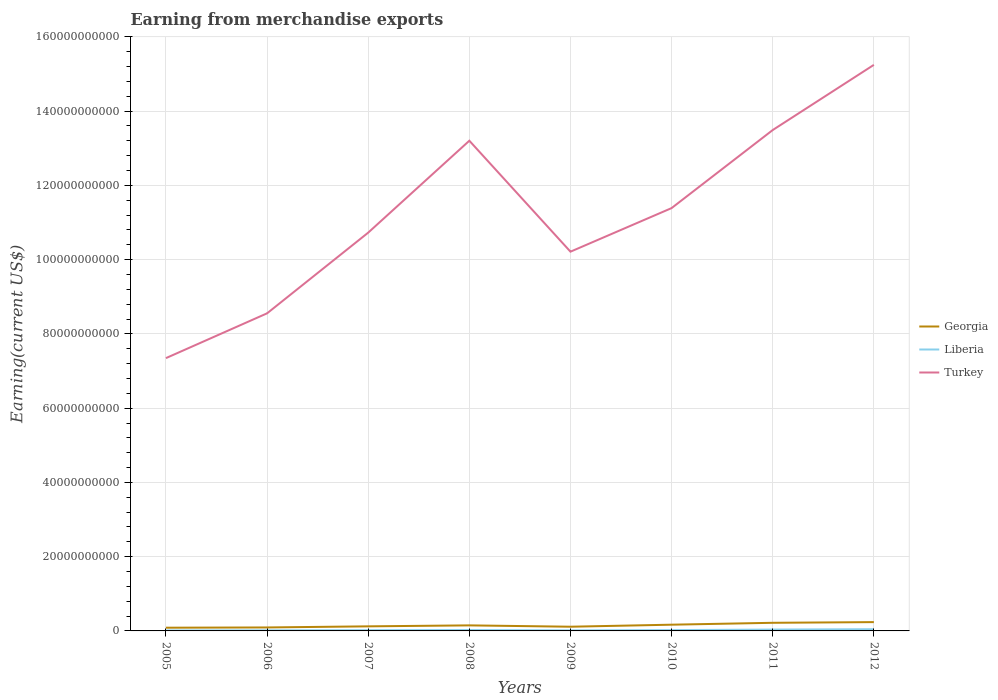How many different coloured lines are there?
Provide a short and direct response. 3. Does the line corresponding to Liberia intersect with the line corresponding to Georgia?
Your response must be concise. No. Across all years, what is the maximum amount earned from merchandise exports in Liberia?
Your answer should be compact. 1.31e+08. What is the total amount earned from merchandise exports in Georgia in the graph?
Provide a succinct answer. -6.30e+08. What is the difference between the highest and the second highest amount earned from merchandise exports in Turkey?
Your answer should be very brief. 7.90e+1. How many lines are there?
Make the answer very short. 3. How many years are there in the graph?
Your response must be concise. 8. Are the values on the major ticks of Y-axis written in scientific E-notation?
Provide a succinct answer. No. Does the graph contain any zero values?
Your response must be concise. No. Does the graph contain grids?
Provide a short and direct response. Yes. Where does the legend appear in the graph?
Offer a terse response. Center right. How many legend labels are there?
Provide a short and direct response. 3. How are the legend labels stacked?
Your response must be concise. Vertical. What is the title of the graph?
Your response must be concise. Earning from merchandise exports. What is the label or title of the X-axis?
Your response must be concise. Years. What is the label or title of the Y-axis?
Your answer should be compact. Earning(current US$). What is the Earning(current US$) in Georgia in 2005?
Ensure brevity in your answer.  8.65e+08. What is the Earning(current US$) of Liberia in 2005?
Provide a short and direct response. 1.31e+08. What is the Earning(current US$) of Turkey in 2005?
Provide a succinct answer. 7.35e+1. What is the Earning(current US$) in Georgia in 2006?
Ensure brevity in your answer.  9.36e+08. What is the Earning(current US$) of Liberia in 2006?
Make the answer very short. 1.58e+08. What is the Earning(current US$) of Turkey in 2006?
Your response must be concise. 8.55e+1. What is the Earning(current US$) in Georgia in 2007?
Offer a terse response. 1.23e+09. What is the Earning(current US$) in Liberia in 2007?
Your answer should be compact. 2.00e+08. What is the Earning(current US$) of Turkey in 2007?
Provide a succinct answer. 1.07e+11. What is the Earning(current US$) of Georgia in 2008?
Keep it short and to the point. 1.50e+09. What is the Earning(current US$) of Liberia in 2008?
Your response must be concise. 2.42e+08. What is the Earning(current US$) of Turkey in 2008?
Provide a short and direct response. 1.32e+11. What is the Earning(current US$) of Georgia in 2009?
Offer a very short reply. 1.13e+09. What is the Earning(current US$) of Liberia in 2009?
Ensure brevity in your answer.  1.49e+08. What is the Earning(current US$) of Turkey in 2009?
Keep it short and to the point. 1.02e+11. What is the Earning(current US$) in Georgia in 2010?
Your answer should be very brief. 1.68e+09. What is the Earning(current US$) in Liberia in 2010?
Give a very brief answer. 2.22e+08. What is the Earning(current US$) in Turkey in 2010?
Offer a very short reply. 1.14e+11. What is the Earning(current US$) of Georgia in 2011?
Offer a terse response. 2.19e+09. What is the Earning(current US$) of Liberia in 2011?
Ensure brevity in your answer.  3.67e+08. What is the Earning(current US$) in Turkey in 2011?
Offer a very short reply. 1.35e+11. What is the Earning(current US$) in Georgia in 2012?
Offer a terse response. 2.38e+09. What is the Earning(current US$) in Liberia in 2012?
Ensure brevity in your answer.  4.60e+08. What is the Earning(current US$) of Turkey in 2012?
Ensure brevity in your answer.  1.52e+11. Across all years, what is the maximum Earning(current US$) of Georgia?
Make the answer very short. 2.38e+09. Across all years, what is the maximum Earning(current US$) in Liberia?
Your response must be concise. 4.60e+08. Across all years, what is the maximum Earning(current US$) of Turkey?
Offer a very short reply. 1.52e+11. Across all years, what is the minimum Earning(current US$) in Georgia?
Your response must be concise. 8.65e+08. Across all years, what is the minimum Earning(current US$) in Liberia?
Offer a very short reply. 1.31e+08. Across all years, what is the minimum Earning(current US$) of Turkey?
Ensure brevity in your answer.  7.35e+1. What is the total Earning(current US$) of Georgia in the graph?
Make the answer very short. 1.19e+1. What is the total Earning(current US$) in Liberia in the graph?
Give a very brief answer. 1.93e+09. What is the total Earning(current US$) in Turkey in the graph?
Your answer should be very brief. 9.02e+11. What is the difference between the Earning(current US$) of Georgia in 2005 and that in 2006?
Your answer should be compact. -7.12e+07. What is the difference between the Earning(current US$) in Liberia in 2005 and that in 2006?
Your answer should be very brief. -2.65e+07. What is the difference between the Earning(current US$) in Turkey in 2005 and that in 2006?
Provide a short and direct response. -1.21e+1. What is the difference between the Earning(current US$) of Georgia in 2005 and that in 2007?
Make the answer very short. -3.67e+08. What is the difference between the Earning(current US$) of Liberia in 2005 and that in 2007?
Your response must be concise. -6.89e+07. What is the difference between the Earning(current US$) of Turkey in 2005 and that in 2007?
Ensure brevity in your answer.  -3.38e+1. What is the difference between the Earning(current US$) of Georgia in 2005 and that in 2008?
Provide a succinct answer. -6.30e+08. What is the difference between the Earning(current US$) in Liberia in 2005 and that in 2008?
Provide a succinct answer. -1.11e+08. What is the difference between the Earning(current US$) in Turkey in 2005 and that in 2008?
Offer a very short reply. -5.86e+1. What is the difference between the Earning(current US$) of Georgia in 2005 and that in 2009?
Ensure brevity in your answer.  -2.69e+08. What is the difference between the Earning(current US$) in Liberia in 2005 and that in 2009?
Offer a terse response. -1.75e+07. What is the difference between the Earning(current US$) of Turkey in 2005 and that in 2009?
Offer a very short reply. -2.87e+1. What is the difference between the Earning(current US$) of Georgia in 2005 and that in 2010?
Offer a terse response. -8.12e+08. What is the difference between the Earning(current US$) in Liberia in 2005 and that in 2010?
Give a very brief answer. -9.07e+07. What is the difference between the Earning(current US$) of Turkey in 2005 and that in 2010?
Your answer should be very brief. -4.04e+1. What is the difference between the Earning(current US$) of Georgia in 2005 and that in 2011?
Make the answer very short. -1.32e+09. What is the difference between the Earning(current US$) of Liberia in 2005 and that in 2011?
Give a very brief answer. -2.36e+08. What is the difference between the Earning(current US$) in Turkey in 2005 and that in 2011?
Offer a very short reply. -6.14e+1. What is the difference between the Earning(current US$) in Georgia in 2005 and that in 2012?
Keep it short and to the point. -1.51e+09. What is the difference between the Earning(current US$) of Liberia in 2005 and that in 2012?
Make the answer very short. -3.28e+08. What is the difference between the Earning(current US$) in Turkey in 2005 and that in 2012?
Offer a terse response. -7.90e+1. What is the difference between the Earning(current US$) in Georgia in 2006 and that in 2007?
Provide a short and direct response. -2.96e+08. What is the difference between the Earning(current US$) in Liberia in 2006 and that in 2007?
Make the answer very short. -4.24e+07. What is the difference between the Earning(current US$) in Turkey in 2006 and that in 2007?
Ensure brevity in your answer.  -2.17e+1. What is the difference between the Earning(current US$) of Georgia in 2006 and that in 2008?
Give a very brief answer. -5.59e+08. What is the difference between the Earning(current US$) in Liberia in 2006 and that in 2008?
Your answer should be compact. -8.46e+07. What is the difference between the Earning(current US$) of Turkey in 2006 and that in 2008?
Keep it short and to the point. -4.65e+1. What is the difference between the Earning(current US$) in Georgia in 2006 and that in 2009?
Give a very brief answer. -1.97e+08. What is the difference between the Earning(current US$) in Liberia in 2006 and that in 2009?
Give a very brief answer. 8.97e+06. What is the difference between the Earning(current US$) in Turkey in 2006 and that in 2009?
Provide a succinct answer. -1.66e+1. What is the difference between the Earning(current US$) in Georgia in 2006 and that in 2010?
Keep it short and to the point. -7.41e+08. What is the difference between the Earning(current US$) in Liberia in 2006 and that in 2010?
Keep it short and to the point. -6.42e+07. What is the difference between the Earning(current US$) of Turkey in 2006 and that in 2010?
Your response must be concise. -2.83e+1. What is the difference between the Earning(current US$) of Georgia in 2006 and that in 2011?
Offer a very short reply. -1.25e+09. What is the difference between the Earning(current US$) of Liberia in 2006 and that in 2011?
Provide a short and direct response. -2.09e+08. What is the difference between the Earning(current US$) of Turkey in 2006 and that in 2011?
Offer a terse response. -4.94e+1. What is the difference between the Earning(current US$) in Georgia in 2006 and that in 2012?
Your answer should be very brief. -1.44e+09. What is the difference between the Earning(current US$) of Liberia in 2006 and that in 2012?
Ensure brevity in your answer.  -3.02e+08. What is the difference between the Earning(current US$) in Turkey in 2006 and that in 2012?
Your answer should be compact. -6.69e+1. What is the difference between the Earning(current US$) in Georgia in 2007 and that in 2008?
Make the answer very short. -2.63e+08. What is the difference between the Earning(current US$) in Liberia in 2007 and that in 2008?
Provide a short and direct response. -4.22e+07. What is the difference between the Earning(current US$) of Turkey in 2007 and that in 2008?
Keep it short and to the point. -2.48e+1. What is the difference between the Earning(current US$) of Georgia in 2007 and that in 2009?
Provide a succinct answer. 9.85e+07. What is the difference between the Earning(current US$) of Liberia in 2007 and that in 2009?
Provide a short and direct response. 5.14e+07. What is the difference between the Earning(current US$) in Turkey in 2007 and that in 2009?
Your response must be concise. 5.13e+09. What is the difference between the Earning(current US$) of Georgia in 2007 and that in 2010?
Give a very brief answer. -4.45e+08. What is the difference between the Earning(current US$) in Liberia in 2007 and that in 2010?
Make the answer very short. -2.18e+07. What is the difference between the Earning(current US$) of Turkey in 2007 and that in 2010?
Your response must be concise. -6.61e+09. What is the difference between the Earning(current US$) in Georgia in 2007 and that in 2011?
Provide a short and direct response. -9.57e+08. What is the difference between the Earning(current US$) in Liberia in 2007 and that in 2011?
Keep it short and to the point. -1.67e+08. What is the difference between the Earning(current US$) in Turkey in 2007 and that in 2011?
Your response must be concise. -2.76e+1. What is the difference between the Earning(current US$) of Georgia in 2007 and that in 2012?
Give a very brief answer. -1.14e+09. What is the difference between the Earning(current US$) of Liberia in 2007 and that in 2012?
Offer a terse response. -2.59e+08. What is the difference between the Earning(current US$) of Turkey in 2007 and that in 2012?
Make the answer very short. -4.52e+1. What is the difference between the Earning(current US$) in Georgia in 2008 and that in 2009?
Your response must be concise. 3.62e+08. What is the difference between the Earning(current US$) of Liberia in 2008 and that in 2009?
Your answer should be compact. 9.36e+07. What is the difference between the Earning(current US$) in Turkey in 2008 and that in 2009?
Your response must be concise. 2.99e+1. What is the difference between the Earning(current US$) in Georgia in 2008 and that in 2010?
Your answer should be compact. -1.82e+08. What is the difference between the Earning(current US$) in Liberia in 2008 and that in 2010?
Give a very brief answer. 2.04e+07. What is the difference between the Earning(current US$) in Turkey in 2008 and that in 2010?
Give a very brief answer. 1.81e+1. What is the difference between the Earning(current US$) of Georgia in 2008 and that in 2011?
Your answer should be compact. -6.94e+08. What is the difference between the Earning(current US$) in Liberia in 2008 and that in 2011?
Offer a terse response. -1.25e+08. What is the difference between the Earning(current US$) in Turkey in 2008 and that in 2011?
Provide a short and direct response. -2.88e+09. What is the difference between the Earning(current US$) of Georgia in 2008 and that in 2012?
Offer a terse response. -8.80e+08. What is the difference between the Earning(current US$) of Liberia in 2008 and that in 2012?
Provide a short and direct response. -2.17e+08. What is the difference between the Earning(current US$) in Turkey in 2008 and that in 2012?
Your answer should be very brief. -2.04e+1. What is the difference between the Earning(current US$) of Georgia in 2009 and that in 2010?
Provide a succinct answer. -5.43e+08. What is the difference between the Earning(current US$) in Liberia in 2009 and that in 2010?
Keep it short and to the point. -7.32e+07. What is the difference between the Earning(current US$) of Turkey in 2009 and that in 2010?
Provide a succinct answer. -1.17e+1. What is the difference between the Earning(current US$) in Georgia in 2009 and that in 2011?
Make the answer very short. -1.06e+09. What is the difference between the Earning(current US$) in Liberia in 2009 and that in 2011?
Offer a terse response. -2.18e+08. What is the difference between the Earning(current US$) of Turkey in 2009 and that in 2011?
Make the answer very short. -3.28e+1. What is the difference between the Earning(current US$) of Georgia in 2009 and that in 2012?
Ensure brevity in your answer.  -1.24e+09. What is the difference between the Earning(current US$) in Liberia in 2009 and that in 2012?
Keep it short and to the point. -3.11e+08. What is the difference between the Earning(current US$) in Turkey in 2009 and that in 2012?
Your answer should be compact. -5.03e+1. What is the difference between the Earning(current US$) in Georgia in 2010 and that in 2011?
Provide a short and direct response. -5.12e+08. What is the difference between the Earning(current US$) in Liberia in 2010 and that in 2011?
Provide a succinct answer. -1.45e+08. What is the difference between the Earning(current US$) of Turkey in 2010 and that in 2011?
Your answer should be compact. -2.10e+1. What is the difference between the Earning(current US$) in Georgia in 2010 and that in 2012?
Keep it short and to the point. -6.98e+08. What is the difference between the Earning(current US$) of Liberia in 2010 and that in 2012?
Offer a terse response. -2.38e+08. What is the difference between the Earning(current US$) in Turkey in 2010 and that in 2012?
Your answer should be very brief. -3.86e+1. What is the difference between the Earning(current US$) in Georgia in 2011 and that in 2012?
Your response must be concise. -1.86e+08. What is the difference between the Earning(current US$) of Liberia in 2011 and that in 2012?
Provide a short and direct response. -9.25e+07. What is the difference between the Earning(current US$) of Turkey in 2011 and that in 2012?
Offer a very short reply. -1.76e+1. What is the difference between the Earning(current US$) of Georgia in 2005 and the Earning(current US$) of Liberia in 2006?
Offer a very short reply. 7.07e+08. What is the difference between the Earning(current US$) in Georgia in 2005 and the Earning(current US$) in Turkey in 2006?
Make the answer very short. -8.47e+1. What is the difference between the Earning(current US$) in Liberia in 2005 and the Earning(current US$) in Turkey in 2006?
Provide a short and direct response. -8.54e+1. What is the difference between the Earning(current US$) of Georgia in 2005 and the Earning(current US$) of Liberia in 2007?
Your answer should be compact. 6.65e+08. What is the difference between the Earning(current US$) of Georgia in 2005 and the Earning(current US$) of Turkey in 2007?
Offer a very short reply. -1.06e+11. What is the difference between the Earning(current US$) in Liberia in 2005 and the Earning(current US$) in Turkey in 2007?
Ensure brevity in your answer.  -1.07e+11. What is the difference between the Earning(current US$) of Georgia in 2005 and the Earning(current US$) of Liberia in 2008?
Make the answer very short. 6.23e+08. What is the difference between the Earning(current US$) in Georgia in 2005 and the Earning(current US$) in Turkey in 2008?
Your response must be concise. -1.31e+11. What is the difference between the Earning(current US$) of Liberia in 2005 and the Earning(current US$) of Turkey in 2008?
Give a very brief answer. -1.32e+11. What is the difference between the Earning(current US$) of Georgia in 2005 and the Earning(current US$) of Liberia in 2009?
Ensure brevity in your answer.  7.16e+08. What is the difference between the Earning(current US$) of Georgia in 2005 and the Earning(current US$) of Turkey in 2009?
Your response must be concise. -1.01e+11. What is the difference between the Earning(current US$) in Liberia in 2005 and the Earning(current US$) in Turkey in 2009?
Ensure brevity in your answer.  -1.02e+11. What is the difference between the Earning(current US$) of Georgia in 2005 and the Earning(current US$) of Liberia in 2010?
Your answer should be very brief. 6.43e+08. What is the difference between the Earning(current US$) in Georgia in 2005 and the Earning(current US$) in Turkey in 2010?
Keep it short and to the point. -1.13e+11. What is the difference between the Earning(current US$) in Liberia in 2005 and the Earning(current US$) in Turkey in 2010?
Your answer should be compact. -1.14e+11. What is the difference between the Earning(current US$) in Georgia in 2005 and the Earning(current US$) in Liberia in 2011?
Your answer should be very brief. 4.98e+08. What is the difference between the Earning(current US$) in Georgia in 2005 and the Earning(current US$) in Turkey in 2011?
Offer a very short reply. -1.34e+11. What is the difference between the Earning(current US$) in Liberia in 2005 and the Earning(current US$) in Turkey in 2011?
Offer a very short reply. -1.35e+11. What is the difference between the Earning(current US$) in Georgia in 2005 and the Earning(current US$) in Liberia in 2012?
Ensure brevity in your answer.  4.06e+08. What is the difference between the Earning(current US$) in Georgia in 2005 and the Earning(current US$) in Turkey in 2012?
Provide a short and direct response. -1.52e+11. What is the difference between the Earning(current US$) in Liberia in 2005 and the Earning(current US$) in Turkey in 2012?
Provide a succinct answer. -1.52e+11. What is the difference between the Earning(current US$) of Georgia in 2006 and the Earning(current US$) of Liberia in 2007?
Provide a succinct answer. 7.36e+08. What is the difference between the Earning(current US$) of Georgia in 2006 and the Earning(current US$) of Turkey in 2007?
Keep it short and to the point. -1.06e+11. What is the difference between the Earning(current US$) in Liberia in 2006 and the Earning(current US$) in Turkey in 2007?
Offer a terse response. -1.07e+11. What is the difference between the Earning(current US$) in Georgia in 2006 and the Earning(current US$) in Liberia in 2008?
Your answer should be compact. 6.94e+08. What is the difference between the Earning(current US$) of Georgia in 2006 and the Earning(current US$) of Turkey in 2008?
Offer a terse response. -1.31e+11. What is the difference between the Earning(current US$) of Liberia in 2006 and the Earning(current US$) of Turkey in 2008?
Keep it short and to the point. -1.32e+11. What is the difference between the Earning(current US$) in Georgia in 2006 and the Earning(current US$) in Liberia in 2009?
Ensure brevity in your answer.  7.87e+08. What is the difference between the Earning(current US$) in Georgia in 2006 and the Earning(current US$) in Turkey in 2009?
Your response must be concise. -1.01e+11. What is the difference between the Earning(current US$) of Liberia in 2006 and the Earning(current US$) of Turkey in 2009?
Provide a succinct answer. -1.02e+11. What is the difference between the Earning(current US$) of Georgia in 2006 and the Earning(current US$) of Liberia in 2010?
Keep it short and to the point. 7.14e+08. What is the difference between the Earning(current US$) in Georgia in 2006 and the Earning(current US$) in Turkey in 2010?
Offer a terse response. -1.13e+11. What is the difference between the Earning(current US$) in Liberia in 2006 and the Earning(current US$) in Turkey in 2010?
Offer a terse response. -1.14e+11. What is the difference between the Earning(current US$) in Georgia in 2006 and the Earning(current US$) in Liberia in 2011?
Your answer should be very brief. 5.69e+08. What is the difference between the Earning(current US$) of Georgia in 2006 and the Earning(current US$) of Turkey in 2011?
Your response must be concise. -1.34e+11. What is the difference between the Earning(current US$) in Liberia in 2006 and the Earning(current US$) in Turkey in 2011?
Your answer should be compact. -1.35e+11. What is the difference between the Earning(current US$) of Georgia in 2006 and the Earning(current US$) of Liberia in 2012?
Make the answer very short. 4.77e+08. What is the difference between the Earning(current US$) of Georgia in 2006 and the Earning(current US$) of Turkey in 2012?
Your response must be concise. -1.52e+11. What is the difference between the Earning(current US$) of Liberia in 2006 and the Earning(current US$) of Turkey in 2012?
Provide a short and direct response. -1.52e+11. What is the difference between the Earning(current US$) in Georgia in 2007 and the Earning(current US$) in Liberia in 2008?
Provide a succinct answer. 9.90e+08. What is the difference between the Earning(current US$) of Georgia in 2007 and the Earning(current US$) of Turkey in 2008?
Keep it short and to the point. -1.31e+11. What is the difference between the Earning(current US$) in Liberia in 2007 and the Earning(current US$) in Turkey in 2008?
Ensure brevity in your answer.  -1.32e+11. What is the difference between the Earning(current US$) in Georgia in 2007 and the Earning(current US$) in Liberia in 2009?
Provide a succinct answer. 1.08e+09. What is the difference between the Earning(current US$) of Georgia in 2007 and the Earning(current US$) of Turkey in 2009?
Your answer should be very brief. -1.01e+11. What is the difference between the Earning(current US$) in Liberia in 2007 and the Earning(current US$) in Turkey in 2009?
Your answer should be compact. -1.02e+11. What is the difference between the Earning(current US$) of Georgia in 2007 and the Earning(current US$) of Liberia in 2010?
Your answer should be very brief. 1.01e+09. What is the difference between the Earning(current US$) in Georgia in 2007 and the Earning(current US$) in Turkey in 2010?
Offer a very short reply. -1.13e+11. What is the difference between the Earning(current US$) in Liberia in 2007 and the Earning(current US$) in Turkey in 2010?
Your answer should be very brief. -1.14e+11. What is the difference between the Earning(current US$) of Georgia in 2007 and the Earning(current US$) of Liberia in 2011?
Your answer should be compact. 8.65e+08. What is the difference between the Earning(current US$) in Georgia in 2007 and the Earning(current US$) in Turkey in 2011?
Give a very brief answer. -1.34e+11. What is the difference between the Earning(current US$) in Liberia in 2007 and the Earning(current US$) in Turkey in 2011?
Keep it short and to the point. -1.35e+11. What is the difference between the Earning(current US$) in Georgia in 2007 and the Earning(current US$) in Liberia in 2012?
Give a very brief answer. 7.73e+08. What is the difference between the Earning(current US$) of Georgia in 2007 and the Earning(current US$) of Turkey in 2012?
Your response must be concise. -1.51e+11. What is the difference between the Earning(current US$) in Liberia in 2007 and the Earning(current US$) in Turkey in 2012?
Your answer should be compact. -1.52e+11. What is the difference between the Earning(current US$) in Georgia in 2008 and the Earning(current US$) in Liberia in 2009?
Provide a short and direct response. 1.35e+09. What is the difference between the Earning(current US$) of Georgia in 2008 and the Earning(current US$) of Turkey in 2009?
Your answer should be very brief. -1.01e+11. What is the difference between the Earning(current US$) in Liberia in 2008 and the Earning(current US$) in Turkey in 2009?
Offer a very short reply. -1.02e+11. What is the difference between the Earning(current US$) of Georgia in 2008 and the Earning(current US$) of Liberia in 2010?
Make the answer very short. 1.27e+09. What is the difference between the Earning(current US$) in Georgia in 2008 and the Earning(current US$) in Turkey in 2010?
Offer a very short reply. -1.12e+11. What is the difference between the Earning(current US$) of Liberia in 2008 and the Earning(current US$) of Turkey in 2010?
Your answer should be compact. -1.14e+11. What is the difference between the Earning(current US$) in Georgia in 2008 and the Earning(current US$) in Liberia in 2011?
Give a very brief answer. 1.13e+09. What is the difference between the Earning(current US$) in Georgia in 2008 and the Earning(current US$) in Turkey in 2011?
Ensure brevity in your answer.  -1.33e+11. What is the difference between the Earning(current US$) in Liberia in 2008 and the Earning(current US$) in Turkey in 2011?
Make the answer very short. -1.35e+11. What is the difference between the Earning(current US$) in Georgia in 2008 and the Earning(current US$) in Liberia in 2012?
Offer a terse response. 1.04e+09. What is the difference between the Earning(current US$) in Georgia in 2008 and the Earning(current US$) in Turkey in 2012?
Your answer should be very brief. -1.51e+11. What is the difference between the Earning(current US$) in Liberia in 2008 and the Earning(current US$) in Turkey in 2012?
Offer a terse response. -1.52e+11. What is the difference between the Earning(current US$) of Georgia in 2009 and the Earning(current US$) of Liberia in 2010?
Your response must be concise. 9.12e+08. What is the difference between the Earning(current US$) in Georgia in 2009 and the Earning(current US$) in Turkey in 2010?
Your answer should be compact. -1.13e+11. What is the difference between the Earning(current US$) of Liberia in 2009 and the Earning(current US$) of Turkey in 2010?
Your response must be concise. -1.14e+11. What is the difference between the Earning(current US$) in Georgia in 2009 and the Earning(current US$) in Liberia in 2011?
Your response must be concise. 7.67e+08. What is the difference between the Earning(current US$) of Georgia in 2009 and the Earning(current US$) of Turkey in 2011?
Keep it short and to the point. -1.34e+11. What is the difference between the Earning(current US$) of Liberia in 2009 and the Earning(current US$) of Turkey in 2011?
Ensure brevity in your answer.  -1.35e+11. What is the difference between the Earning(current US$) in Georgia in 2009 and the Earning(current US$) in Liberia in 2012?
Provide a short and direct response. 6.74e+08. What is the difference between the Earning(current US$) of Georgia in 2009 and the Earning(current US$) of Turkey in 2012?
Provide a succinct answer. -1.51e+11. What is the difference between the Earning(current US$) in Liberia in 2009 and the Earning(current US$) in Turkey in 2012?
Ensure brevity in your answer.  -1.52e+11. What is the difference between the Earning(current US$) of Georgia in 2010 and the Earning(current US$) of Liberia in 2011?
Provide a short and direct response. 1.31e+09. What is the difference between the Earning(current US$) of Georgia in 2010 and the Earning(current US$) of Turkey in 2011?
Give a very brief answer. -1.33e+11. What is the difference between the Earning(current US$) in Liberia in 2010 and the Earning(current US$) in Turkey in 2011?
Your response must be concise. -1.35e+11. What is the difference between the Earning(current US$) in Georgia in 2010 and the Earning(current US$) in Liberia in 2012?
Provide a succinct answer. 1.22e+09. What is the difference between the Earning(current US$) of Georgia in 2010 and the Earning(current US$) of Turkey in 2012?
Give a very brief answer. -1.51e+11. What is the difference between the Earning(current US$) of Liberia in 2010 and the Earning(current US$) of Turkey in 2012?
Give a very brief answer. -1.52e+11. What is the difference between the Earning(current US$) of Georgia in 2011 and the Earning(current US$) of Liberia in 2012?
Your response must be concise. 1.73e+09. What is the difference between the Earning(current US$) in Georgia in 2011 and the Earning(current US$) in Turkey in 2012?
Make the answer very short. -1.50e+11. What is the difference between the Earning(current US$) of Liberia in 2011 and the Earning(current US$) of Turkey in 2012?
Your answer should be compact. -1.52e+11. What is the average Earning(current US$) of Georgia per year?
Provide a succinct answer. 1.49e+09. What is the average Earning(current US$) in Liberia per year?
Offer a very short reply. 2.41e+08. What is the average Earning(current US$) in Turkey per year?
Offer a very short reply. 1.13e+11. In the year 2005, what is the difference between the Earning(current US$) in Georgia and Earning(current US$) in Liberia?
Provide a short and direct response. 7.34e+08. In the year 2005, what is the difference between the Earning(current US$) in Georgia and Earning(current US$) in Turkey?
Provide a short and direct response. -7.26e+1. In the year 2005, what is the difference between the Earning(current US$) in Liberia and Earning(current US$) in Turkey?
Your answer should be compact. -7.33e+1. In the year 2006, what is the difference between the Earning(current US$) of Georgia and Earning(current US$) of Liberia?
Give a very brief answer. 7.78e+08. In the year 2006, what is the difference between the Earning(current US$) in Georgia and Earning(current US$) in Turkey?
Your response must be concise. -8.46e+1. In the year 2006, what is the difference between the Earning(current US$) of Liberia and Earning(current US$) of Turkey?
Give a very brief answer. -8.54e+1. In the year 2007, what is the difference between the Earning(current US$) in Georgia and Earning(current US$) in Liberia?
Offer a very short reply. 1.03e+09. In the year 2007, what is the difference between the Earning(current US$) in Georgia and Earning(current US$) in Turkey?
Your answer should be compact. -1.06e+11. In the year 2007, what is the difference between the Earning(current US$) of Liberia and Earning(current US$) of Turkey?
Offer a terse response. -1.07e+11. In the year 2008, what is the difference between the Earning(current US$) of Georgia and Earning(current US$) of Liberia?
Give a very brief answer. 1.25e+09. In the year 2008, what is the difference between the Earning(current US$) of Georgia and Earning(current US$) of Turkey?
Ensure brevity in your answer.  -1.31e+11. In the year 2008, what is the difference between the Earning(current US$) in Liberia and Earning(current US$) in Turkey?
Ensure brevity in your answer.  -1.32e+11. In the year 2009, what is the difference between the Earning(current US$) of Georgia and Earning(current US$) of Liberia?
Your response must be concise. 9.85e+08. In the year 2009, what is the difference between the Earning(current US$) in Georgia and Earning(current US$) in Turkey?
Offer a terse response. -1.01e+11. In the year 2009, what is the difference between the Earning(current US$) of Liberia and Earning(current US$) of Turkey?
Provide a short and direct response. -1.02e+11. In the year 2010, what is the difference between the Earning(current US$) of Georgia and Earning(current US$) of Liberia?
Offer a terse response. 1.46e+09. In the year 2010, what is the difference between the Earning(current US$) of Georgia and Earning(current US$) of Turkey?
Your answer should be compact. -1.12e+11. In the year 2010, what is the difference between the Earning(current US$) in Liberia and Earning(current US$) in Turkey?
Offer a very short reply. -1.14e+11. In the year 2011, what is the difference between the Earning(current US$) of Georgia and Earning(current US$) of Liberia?
Your answer should be compact. 1.82e+09. In the year 2011, what is the difference between the Earning(current US$) in Georgia and Earning(current US$) in Turkey?
Provide a succinct answer. -1.33e+11. In the year 2011, what is the difference between the Earning(current US$) in Liberia and Earning(current US$) in Turkey?
Ensure brevity in your answer.  -1.35e+11. In the year 2012, what is the difference between the Earning(current US$) of Georgia and Earning(current US$) of Liberia?
Offer a very short reply. 1.92e+09. In the year 2012, what is the difference between the Earning(current US$) of Georgia and Earning(current US$) of Turkey?
Offer a terse response. -1.50e+11. In the year 2012, what is the difference between the Earning(current US$) of Liberia and Earning(current US$) of Turkey?
Offer a terse response. -1.52e+11. What is the ratio of the Earning(current US$) in Georgia in 2005 to that in 2006?
Ensure brevity in your answer.  0.92. What is the ratio of the Earning(current US$) in Liberia in 2005 to that in 2006?
Provide a short and direct response. 0.83. What is the ratio of the Earning(current US$) of Turkey in 2005 to that in 2006?
Provide a short and direct response. 0.86. What is the ratio of the Earning(current US$) of Georgia in 2005 to that in 2007?
Keep it short and to the point. 0.7. What is the ratio of the Earning(current US$) in Liberia in 2005 to that in 2007?
Your response must be concise. 0.66. What is the ratio of the Earning(current US$) in Turkey in 2005 to that in 2007?
Offer a terse response. 0.69. What is the ratio of the Earning(current US$) of Georgia in 2005 to that in 2008?
Provide a succinct answer. 0.58. What is the ratio of the Earning(current US$) of Liberia in 2005 to that in 2008?
Your response must be concise. 0.54. What is the ratio of the Earning(current US$) of Turkey in 2005 to that in 2008?
Keep it short and to the point. 0.56. What is the ratio of the Earning(current US$) of Georgia in 2005 to that in 2009?
Ensure brevity in your answer.  0.76. What is the ratio of the Earning(current US$) of Liberia in 2005 to that in 2009?
Keep it short and to the point. 0.88. What is the ratio of the Earning(current US$) of Turkey in 2005 to that in 2009?
Your answer should be very brief. 0.72. What is the ratio of the Earning(current US$) in Georgia in 2005 to that in 2010?
Ensure brevity in your answer.  0.52. What is the ratio of the Earning(current US$) in Liberia in 2005 to that in 2010?
Make the answer very short. 0.59. What is the ratio of the Earning(current US$) of Turkey in 2005 to that in 2010?
Give a very brief answer. 0.65. What is the ratio of the Earning(current US$) in Georgia in 2005 to that in 2011?
Make the answer very short. 0.4. What is the ratio of the Earning(current US$) of Liberia in 2005 to that in 2011?
Provide a short and direct response. 0.36. What is the ratio of the Earning(current US$) in Turkey in 2005 to that in 2011?
Make the answer very short. 0.54. What is the ratio of the Earning(current US$) in Georgia in 2005 to that in 2012?
Your answer should be compact. 0.36. What is the ratio of the Earning(current US$) of Liberia in 2005 to that in 2012?
Your answer should be compact. 0.29. What is the ratio of the Earning(current US$) in Turkey in 2005 to that in 2012?
Give a very brief answer. 0.48. What is the ratio of the Earning(current US$) of Georgia in 2006 to that in 2007?
Provide a succinct answer. 0.76. What is the ratio of the Earning(current US$) in Liberia in 2006 to that in 2007?
Offer a very short reply. 0.79. What is the ratio of the Earning(current US$) of Turkey in 2006 to that in 2007?
Offer a terse response. 0.8. What is the ratio of the Earning(current US$) in Georgia in 2006 to that in 2008?
Give a very brief answer. 0.63. What is the ratio of the Earning(current US$) of Liberia in 2006 to that in 2008?
Keep it short and to the point. 0.65. What is the ratio of the Earning(current US$) of Turkey in 2006 to that in 2008?
Provide a short and direct response. 0.65. What is the ratio of the Earning(current US$) of Georgia in 2006 to that in 2009?
Provide a short and direct response. 0.83. What is the ratio of the Earning(current US$) in Liberia in 2006 to that in 2009?
Give a very brief answer. 1.06. What is the ratio of the Earning(current US$) of Turkey in 2006 to that in 2009?
Offer a very short reply. 0.84. What is the ratio of the Earning(current US$) of Georgia in 2006 to that in 2010?
Provide a succinct answer. 0.56. What is the ratio of the Earning(current US$) in Liberia in 2006 to that in 2010?
Offer a terse response. 0.71. What is the ratio of the Earning(current US$) in Turkey in 2006 to that in 2010?
Keep it short and to the point. 0.75. What is the ratio of the Earning(current US$) of Georgia in 2006 to that in 2011?
Offer a very short reply. 0.43. What is the ratio of the Earning(current US$) in Liberia in 2006 to that in 2011?
Your response must be concise. 0.43. What is the ratio of the Earning(current US$) of Turkey in 2006 to that in 2011?
Keep it short and to the point. 0.63. What is the ratio of the Earning(current US$) in Georgia in 2006 to that in 2012?
Keep it short and to the point. 0.39. What is the ratio of the Earning(current US$) in Liberia in 2006 to that in 2012?
Ensure brevity in your answer.  0.34. What is the ratio of the Earning(current US$) in Turkey in 2006 to that in 2012?
Ensure brevity in your answer.  0.56. What is the ratio of the Earning(current US$) in Georgia in 2007 to that in 2008?
Give a very brief answer. 0.82. What is the ratio of the Earning(current US$) in Liberia in 2007 to that in 2008?
Provide a short and direct response. 0.83. What is the ratio of the Earning(current US$) in Turkey in 2007 to that in 2008?
Your answer should be very brief. 0.81. What is the ratio of the Earning(current US$) in Georgia in 2007 to that in 2009?
Your answer should be compact. 1.09. What is the ratio of the Earning(current US$) in Liberia in 2007 to that in 2009?
Your answer should be compact. 1.35. What is the ratio of the Earning(current US$) of Turkey in 2007 to that in 2009?
Offer a very short reply. 1.05. What is the ratio of the Earning(current US$) in Georgia in 2007 to that in 2010?
Ensure brevity in your answer.  0.73. What is the ratio of the Earning(current US$) in Liberia in 2007 to that in 2010?
Provide a succinct answer. 0.9. What is the ratio of the Earning(current US$) in Turkey in 2007 to that in 2010?
Your answer should be compact. 0.94. What is the ratio of the Earning(current US$) of Georgia in 2007 to that in 2011?
Provide a succinct answer. 0.56. What is the ratio of the Earning(current US$) in Liberia in 2007 to that in 2011?
Your answer should be compact. 0.55. What is the ratio of the Earning(current US$) of Turkey in 2007 to that in 2011?
Make the answer very short. 0.8. What is the ratio of the Earning(current US$) in Georgia in 2007 to that in 2012?
Provide a succinct answer. 0.52. What is the ratio of the Earning(current US$) in Liberia in 2007 to that in 2012?
Your answer should be compact. 0.44. What is the ratio of the Earning(current US$) in Turkey in 2007 to that in 2012?
Your answer should be compact. 0.7. What is the ratio of the Earning(current US$) in Georgia in 2008 to that in 2009?
Give a very brief answer. 1.32. What is the ratio of the Earning(current US$) of Liberia in 2008 to that in 2009?
Give a very brief answer. 1.63. What is the ratio of the Earning(current US$) in Turkey in 2008 to that in 2009?
Offer a terse response. 1.29. What is the ratio of the Earning(current US$) in Georgia in 2008 to that in 2010?
Make the answer very short. 0.89. What is the ratio of the Earning(current US$) of Liberia in 2008 to that in 2010?
Ensure brevity in your answer.  1.09. What is the ratio of the Earning(current US$) in Turkey in 2008 to that in 2010?
Ensure brevity in your answer.  1.16. What is the ratio of the Earning(current US$) of Georgia in 2008 to that in 2011?
Your answer should be very brief. 0.68. What is the ratio of the Earning(current US$) in Liberia in 2008 to that in 2011?
Your response must be concise. 0.66. What is the ratio of the Earning(current US$) of Turkey in 2008 to that in 2011?
Keep it short and to the point. 0.98. What is the ratio of the Earning(current US$) in Georgia in 2008 to that in 2012?
Offer a terse response. 0.63. What is the ratio of the Earning(current US$) of Liberia in 2008 to that in 2012?
Keep it short and to the point. 0.53. What is the ratio of the Earning(current US$) of Turkey in 2008 to that in 2012?
Keep it short and to the point. 0.87. What is the ratio of the Earning(current US$) in Georgia in 2009 to that in 2010?
Offer a terse response. 0.68. What is the ratio of the Earning(current US$) of Liberia in 2009 to that in 2010?
Give a very brief answer. 0.67. What is the ratio of the Earning(current US$) in Turkey in 2009 to that in 2010?
Keep it short and to the point. 0.9. What is the ratio of the Earning(current US$) of Georgia in 2009 to that in 2011?
Provide a succinct answer. 0.52. What is the ratio of the Earning(current US$) of Liberia in 2009 to that in 2011?
Keep it short and to the point. 0.41. What is the ratio of the Earning(current US$) of Turkey in 2009 to that in 2011?
Provide a short and direct response. 0.76. What is the ratio of the Earning(current US$) in Georgia in 2009 to that in 2012?
Provide a short and direct response. 0.48. What is the ratio of the Earning(current US$) of Liberia in 2009 to that in 2012?
Keep it short and to the point. 0.32. What is the ratio of the Earning(current US$) in Turkey in 2009 to that in 2012?
Your answer should be compact. 0.67. What is the ratio of the Earning(current US$) of Georgia in 2010 to that in 2011?
Offer a very short reply. 0.77. What is the ratio of the Earning(current US$) of Liberia in 2010 to that in 2011?
Offer a terse response. 0.6. What is the ratio of the Earning(current US$) in Turkey in 2010 to that in 2011?
Offer a very short reply. 0.84. What is the ratio of the Earning(current US$) in Georgia in 2010 to that in 2012?
Your answer should be compact. 0.71. What is the ratio of the Earning(current US$) of Liberia in 2010 to that in 2012?
Make the answer very short. 0.48. What is the ratio of the Earning(current US$) of Turkey in 2010 to that in 2012?
Make the answer very short. 0.75. What is the ratio of the Earning(current US$) of Georgia in 2011 to that in 2012?
Make the answer very short. 0.92. What is the ratio of the Earning(current US$) of Liberia in 2011 to that in 2012?
Ensure brevity in your answer.  0.8. What is the ratio of the Earning(current US$) of Turkey in 2011 to that in 2012?
Provide a short and direct response. 0.88. What is the difference between the highest and the second highest Earning(current US$) of Georgia?
Provide a succinct answer. 1.86e+08. What is the difference between the highest and the second highest Earning(current US$) of Liberia?
Your answer should be very brief. 9.25e+07. What is the difference between the highest and the second highest Earning(current US$) of Turkey?
Your answer should be very brief. 1.76e+1. What is the difference between the highest and the lowest Earning(current US$) of Georgia?
Make the answer very short. 1.51e+09. What is the difference between the highest and the lowest Earning(current US$) of Liberia?
Give a very brief answer. 3.28e+08. What is the difference between the highest and the lowest Earning(current US$) in Turkey?
Your answer should be compact. 7.90e+1. 